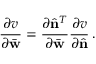Convert formula to latex. <formula><loc_0><loc_0><loc_500><loc_500>\frac { \partial v } { \partial \bar { w } } = \frac { \partial \hat { n } ^ { T } } { \partial \bar { w } } \frac { \partial v } { \partial \hat { n } } \, .</formula> 